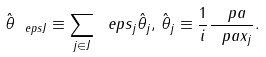Convert formula to latex. <formula><loc_0><loc_0><loc_500><loc_500>\hat { \theta } _ { \ e p s J } \equiv \sum _ { j \in J } \ e p s _ { j } \hat { \theta } _ { j } , \, \hat { \theta } _ { j } \equiv \frac { 1 } { i } \frac { \ p a } { \ p a x _ { j } } .</formula> 